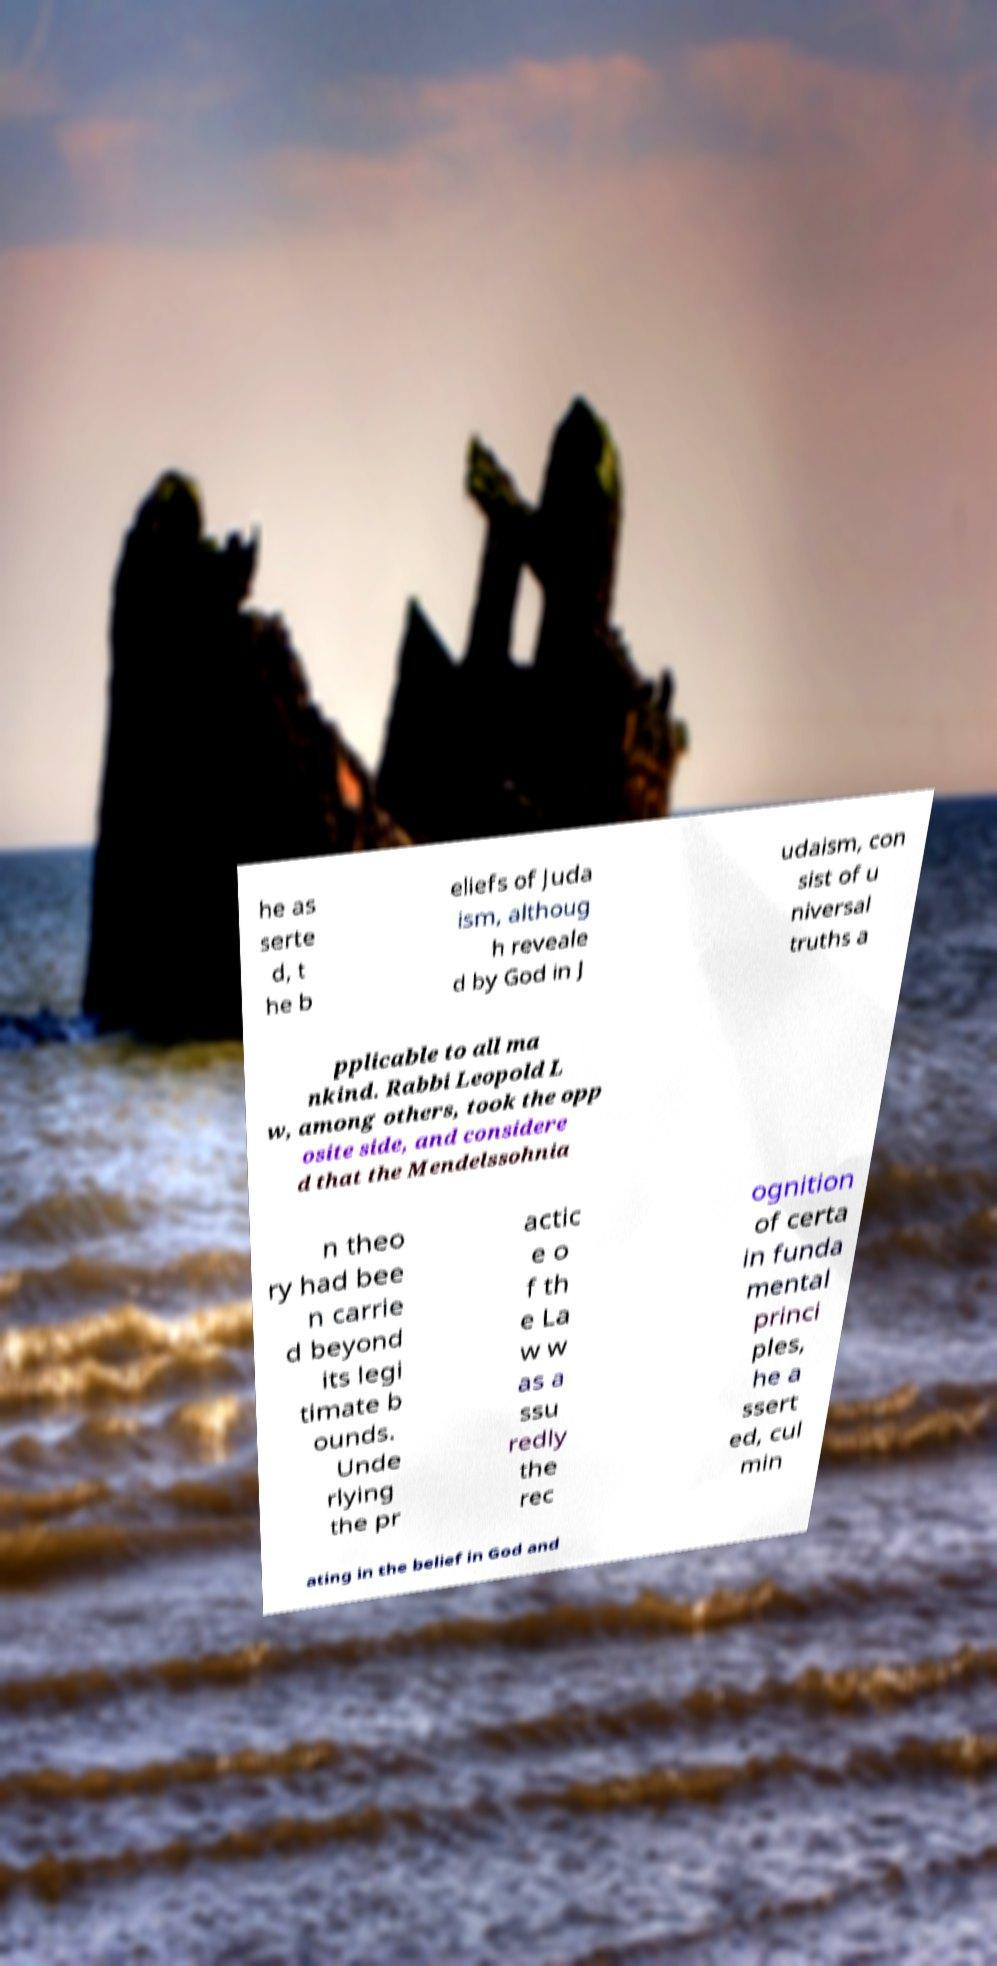What messages or text are displayed in this image? I need them in a readable, typed format. he as serte d, t he b eliefs of Juda ism, althoug h reveale d by God in J udaism, con sist of u niversal truths a pplicable to all ma nkind. Rabbi Leopold L w, among others, took the opp osite side, and considere d that the Mendelssohnia n theo ry had bee n carrie d beyond its legi timate b ounds. Unde rlying the pr actic e o f th e La w w as a ssu redly the rec ognition of certa in funda mental princi ples, he a ssert ed, cul min ating in the belief in God and 